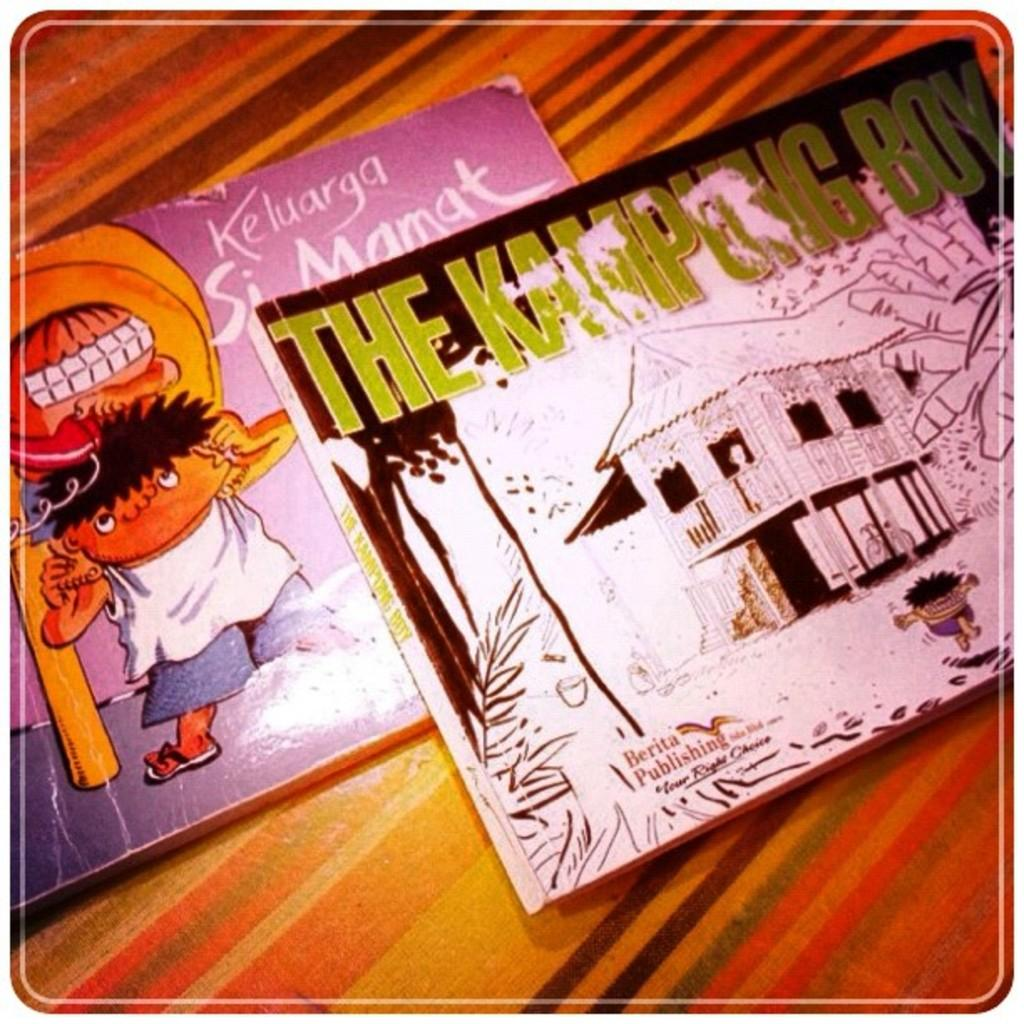<image>
Present a compact description of the photo's key features. A book cover has the word Keluarga on it. 